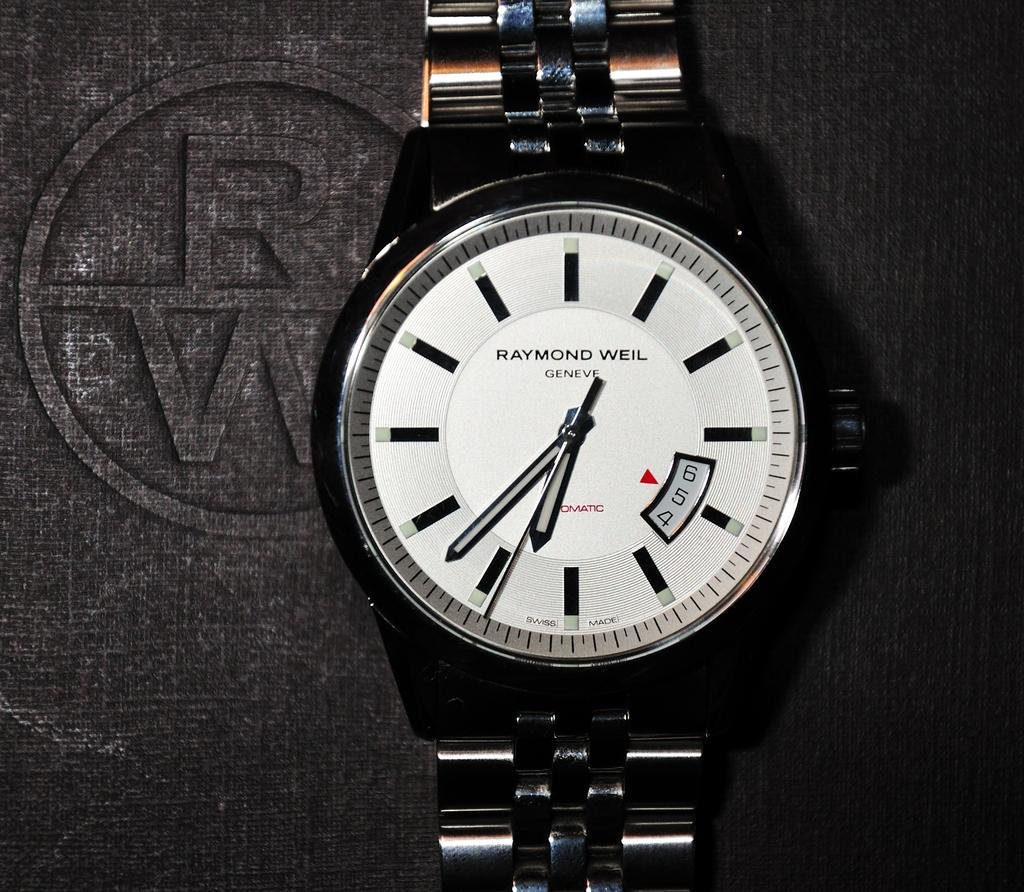What object is present in the image? There is a watch in the image. What brand is the watch in the image? The watch has "Raymond Weil" written on it. How many men are playing with a ball on the trail in the image? There are no men, balls, or trails present in the image; it only features a watch with "Raymond Weil" written on it. 